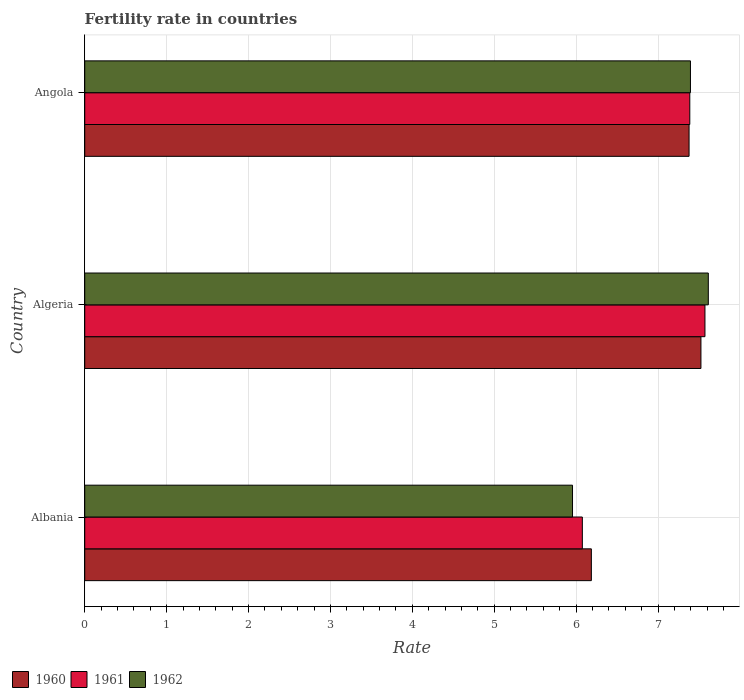Are the number of bars per tick equal to the number of legend labels?
Make the answer very short. Yes. Are the number of bars on each tick of the Y-axis equal?
Give a very brief answer. Yes. What is the label of the 2nd group of bars from the top?
Provide a succinct answer. Algeria. In how many cases, is the number of bars for a given country not equal to the number of legend labels?
Keep it short and to the point. 0. What is the fertility rate in 1960 in Algeria?
Keep it short and to the point. 7.52. Across all countries, what is the maximum fertility rate in 1962?
Your answer should be compact. 7.61. Across all countries, what is the minimum fertility rate in 1960?
Ensure brevity in your answer.  6.19. In which country was the fertility rate in 1960 maximum?
Your response must be concise. Algeria. In which country was the fertility rate in 1961 minimum?
Offer a terse response. Albania. What is the total fertility rate in 1962 in the graph?
Give a very brief answer. 20.97. What is the difference between the fertility rate in 1960 in Albania and that in Algeria?
Provide a succinct answer. -1.34. What is the difference between the fertility rate in 1962 in Algeria and the fertility rate in 1960 in Albania?
Give a very brief answer. 1.43. What is the average fertility rate in 1962 per country?
Your response must be concise. 6.99. What is the difference between the fertility rate in 1961 and fertility rate in 1962 in Algeria?
Provide a succinct answer. -0.04. In how many countries, is the fertility rate in 1961 greater than 2 ?
Your response must be concise. 3. What is the ratio of the fertility rate in 1961 in Algeria to that in Angola?
Keep it short and to the point. 1.03. Is the fertility rate in 1962 in Albania less than that in Angola?
Provide a short and direct response. Yes. What is the difference between the highest and the second highest fertility rate in 1960?
Provide a short and direct response. 0.15. What is the difference between the highest and the lowest fertility rate in 1960?
Provide a succinct answer. 1.34. Is the sum of the fertility rate in 1960 in Albania and Algeria greater than the maximum fertility rate in 1961 across all countries?
Offer a very short reply. Yes. What does the 2nd bar from the top in Angola represents?
Give a very brief answer. 1961. Is it the case that in every country, the sum of the fertility rate in 1960 and fertility rate in 1962 is greater than the fertility rate in 1961?
Give a very brief answer. Yes. How many bars are there?
Provide a short and direct response. 9. What is the difference between two consecutive major ticks on the X-axis?
Keep it short and to the point. 1. Are the values on the major ticks of X-axis written in scientific E-notation?
Ensure brevity in your answer.  No. Where does the legend appear in the graph?
Offer a terse response. Bottom left. How many legend labels are there?
Offer a terse response. 3. What is the title of the graph?
Your answer should be very brief. Fertility rate in countries. What is the label or title of the X-axis?
Provide a short and direct response. Rate. What is the label or title of the Y-axis?
Ensure brevity in your answer.  Country. What is the Rate of 1960 in Albania?
Your answer should be very brief. 6.19. What is the Rate in 1961 in Albania?
Keep it short and to the point. 6.08. What is the Rate of 1962 in Albania?
Your answer should be very brief. 5.96. What is the Rate in 1960 in Algeria?
Give a very brief answer. 7.52. What is the Rate in 1961 in Algeria?
Give a very brief answer. 7.57. What is the Rate of 1962 in Algeria?
Keep it short and to the point. 7.61. What is the Rate of 1960 in Angola?
Provide a short and direct response. 7.38. What is the Rate of 1961 in Angola?
Provide a succinct answer. 7.39. What is the Rate in 1962 in Angola?
Keep it short and to the point. 7.4. Across all countries, what is the maximum Rate of 1960?
Keep it short and to the point. 7.52. Across all countries, what is the maximum Rate of 1961?
Make the answer very short. 7.57. Across all countries, what is the maximum Rate of 1962?
Offer a terse response. 7.61. Across all countries, what is the minimum Rate of 1960?
Keep it short and to the point. 6.19. Across all countries, what is the minimum Rate of 1961?
Provide a succinct answer. 6.08. Across all countries, what is the minimum Rate of 1962?
Give a very brief answer. 5.96. What is the total Rate of 1960 in the graph?
Offer a very short reply. 21.09. What is the total Rate of 1961 in the graph?
Offer a very short reply. 21.04. What is the total Rate in 1962 in the graph?
Make the answer very short. 20.97. What is the difference between the Rate of 1960 in Albania and that in Algeria?
Ensure brevity in your answer.  -1.34. What is the difference between the Rate of 1961 in Albania and that in Algeria?
Your answer should be compact. -1.5. What is the difference between the Rate in 1962 in Albania and that in Algeria?
Your response must be concise. -1.66. What is the difference between the Rate in 1960 in Albania and that in Angola?
Your response must be concise. -1.19. What is the difference between the Rate of 1961 in Albania and that in Angola?
Ensure brevity in your answer.  -1.31. What is the difference between the Rate of 1962 in Albania and that in Angola?
Offer a very short reply. -1.44. What is the difference between the Rate of 1960 in Algeria and that in Angola?
Offer a terse response. 0.14. What is the difference between the Rate in 1961 in Algeria and that in Angola?
Provide a short and direct response. 0.18. What is the difference between the Rate in 1962 in Algeria and that in Angola?
Your response must be concise. 0.22. What is the difference between the Rate in 1960 in Albania and the Rate in 1961 in Algeria?
Make the answer very short. -1.39. What is the difference between the Rate in 1960 in Albania and the Rate in 1962 in Algeria?
Your response must be concise. -1.43. What is the difference between the Rate in 1961 in Albania and the Rate in 1962 in Algeria?
Keep it short and to the point. -1.54. What is the difference between the Rate of 1960 in Albania and the Rate of 1961 in Angola?
Keep it short and to the point. -1.2. What is the difference between the Rate of 1960 in Albania and the Rate of 1962 in Angola?
Ensure brevity in your answer.  -1.21. What is the difference between the Rate of 1961 in Albania and the Rate of 1962 in Angola?
Offer a terse response. -1.32. What is the difference between the Rate in 1960 in Algeria and the Rate in 1961 in Angola?
Provide a short and direct response. 0.14. What is the difference between the Rate in 1960 in Algeria and the Rate in 1962 in Angola?
Offer a terse response. 0.13. What is the difference between the Rate in 1961 in Algeria and the Rate in 1962 in Angola?
Your answer should be very brief. 0.18. What is the average Rate in 1960 per country?
Offer a terse response. 7.03. What is the average Rate of 1961 per country?
Provide a short and direct response. 7.01. What is the average Rate of 1962 per country?
Provide a short and direct response. 6.99. What is the difference between the Rate in 1960 and Rate in 1961 in Albania?
Provide a short and direct response. 0.11. What is the difference between the Rate in 1960 and Rate in 1962 in Albania?
Your answer should be very brief. 0.23. What is the difference between the Rate of 1961 and Rate of 1962 in Albania?
Your answer should be very brief. 0.12. What is the difference between the Rate in 1960 and Rate in 1961 in Algeria?
Ensure brevity in your answer.  -0.05. What is the difference between the Rate of 1960 and Rate of 1962 in Algeria?
Give a very brief answer. -0.09. What is the difference between the Rate of 1961 and Rate of 1962 in Algeria?
Provide a succinct answer. -0.04. What is the difference between the Rate of 1960 and Rate of 1961 in Angola?
Provide a succinct answer. -0.01. What is the difference between the Rate of 1960 and Rate of 1962 in Angola?
Provide a succinct answer. -0.02. What is the difference between the Rate in 1961 and Rate in 1962 in Angola?
Offer a very short reply. -0.01. What is the ratio of the Rate of 1960 in Albania to that in Algeria?
Keep it short and to the point. 0.82. What is the ratio of the Rate of 1961 in Albania to that in Algeria?
Your answer should be very brief. 0.8. What is the ratio of the Rate of 1962 in Albania to that in Algeria?
Offer a terse response. 0.78. What is the ratio of the Rate in 1960 in Albania to that in Angola?
Your answer should be compact. 0.84. What is the ratio of the Rate of 1961 in Albania to that in Angola?
Keep it short and to the point. 0.82. What is the ratio of the Rate in 1962 in Albania to that in Angola?
Offer a terse response. 0.81. What is the ratio of the Rate in 1960 in Algeria to that in Angola?
Offer a terse response. 1.02. What is the ratio of the Rate in 1962 in Algeria to that in Angola?
Your response must be concise. 1.03. What is the difference between the highest and the second highest Rate of 1960?
Provide a succinct answer. 0.14. What is the difference between the highest and the second highest Rate in 1961?
Offer a terse response. 0.18. What is the difference between the highest and the second highest Rate in 1962?
Your answer should be compact. 0.22. What is the difference between the highest and the lowest Rate in 1960?
Offer a very short reply. 1.34. What is the difference between the highest and the lowest Rate of 1961?
Your answer should be very brief. 1.5. What is the difference between the highest and the lowest Rate in 1962?
Keep it short and to the point. 1.66. 